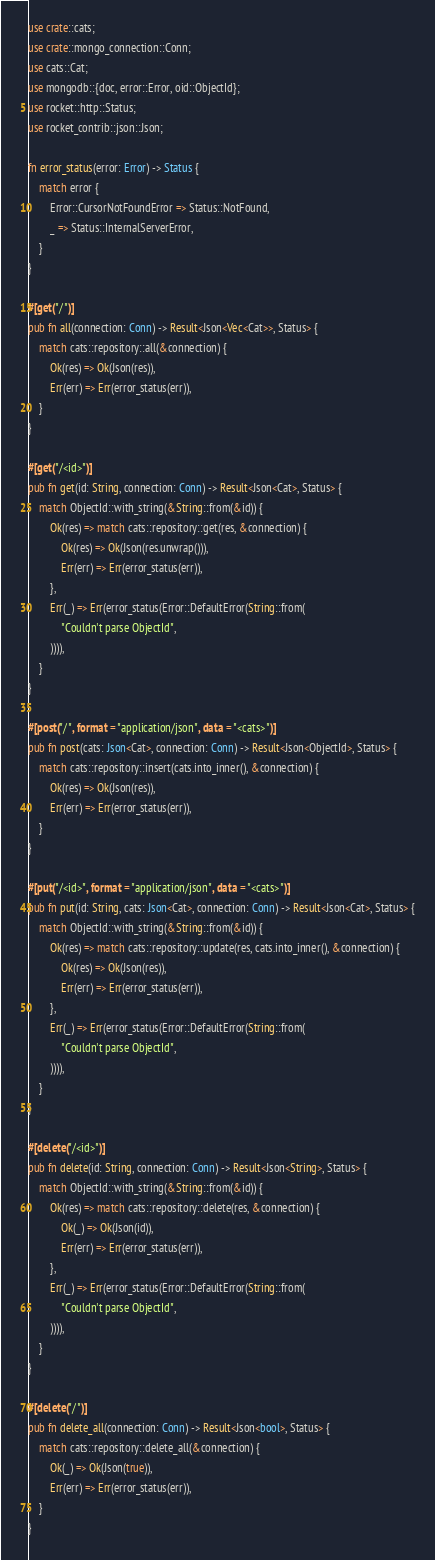Convert code to text. <code><loc_0><loc_0><loc_500><loc_500><_Rust_>use crate::cats;
use crate::mongo_connection::Conn;
use cats::Cat;
use mongodb::{doc, error::Error, oid::ObjectId};
use rocket::http::Status;
use rocket_contrib::json::Json;

fn error_status(error: Error) -> Status {
    match error {
        Error::CursorNotFoundError => Status::NotFound,
        _ => Status::InternalServerError,
    }
}

#[get("/")]
pub fn all(connection: Conn) -> Result<Json<Vec<Cat>>, Status> {
    match cats::repository::all(&connection) {
        Ok(res) => Ok(Json(res)),
        Err(err) => Err(error_status(err)),
    }
}

#[get("/<id>")]
pub fn get(id: String, connection: Conn) -> Result<Json<Cat>, Status> {
    match ObjectId::with_string(&String::from(&id)) {
        Ok(res) => match cats::repository::get(res, &connection) {
            Ok(res) => Ok(Json(res.unwrap())),
            Err(err) => Err(error_status(err)),
        },
        Err(_) => Err(error_status(Error::DefaultError(String::from(
            "Couldn't parse ObjectId",
        )))),
    }
}

#[post("/", format = "application/json", data = "<cats>")]
pub fn post(cats: Json<Cat>, connection: Conn) -> Result<Json<ObjectId>, Status> {
    match cats::repository::insert(cats.into_inner(), &connection) {
        Ok(res) => Ok(Json(res)),
        Err(err) => Err(error_status(err)),
    }
}

#[put("/<id>", format = "application/json", data = "<cats>")]
pub fn put(id: String, cats: Json<Cat>, connection: Conn) -> Result<Json<Cat>, Status> {
    match ObjectId::with_string(&String::from(&id)) {
        Ok(res) => match cats::repository::update(res, cats.into_inner(), &connection) {
            Ok(res) => Ok(Json(res)),
            Err(err) => Err(error_status(err)),
        },
        Err(_) => Err(error_status(Error::DefaultError(String::from(
            "Couldn't parse ObjectId",
        )))),
    }
}

#[delete("/<id>")]
pub fn delete(id: String, connection: Conn) -> Result<Json<String>, Status> {
    match ObjectId::with_string(&String::from(&id)) {
        Ok(res) => match cats::repository::delete(res, &connection) {
            Ok(_) => Ok(Json(id)),
            Err(err) => Err(error_status(err)),
        },
        Err(_) => Err(error_status(Error::DefaultError(String::from(
            "Couldn't parse ObjectId",
        )))),
    }
}

#[delete("/")]
pub fn delete_all(connection: Conn) -> Result<Json<bool>, Status> {
    match cats::repository::delete_all(&connection) {
        Ok(_) => Ok(Json(true)),
        Err(err) => Err(error_status(err)),
    }
}
</code> 